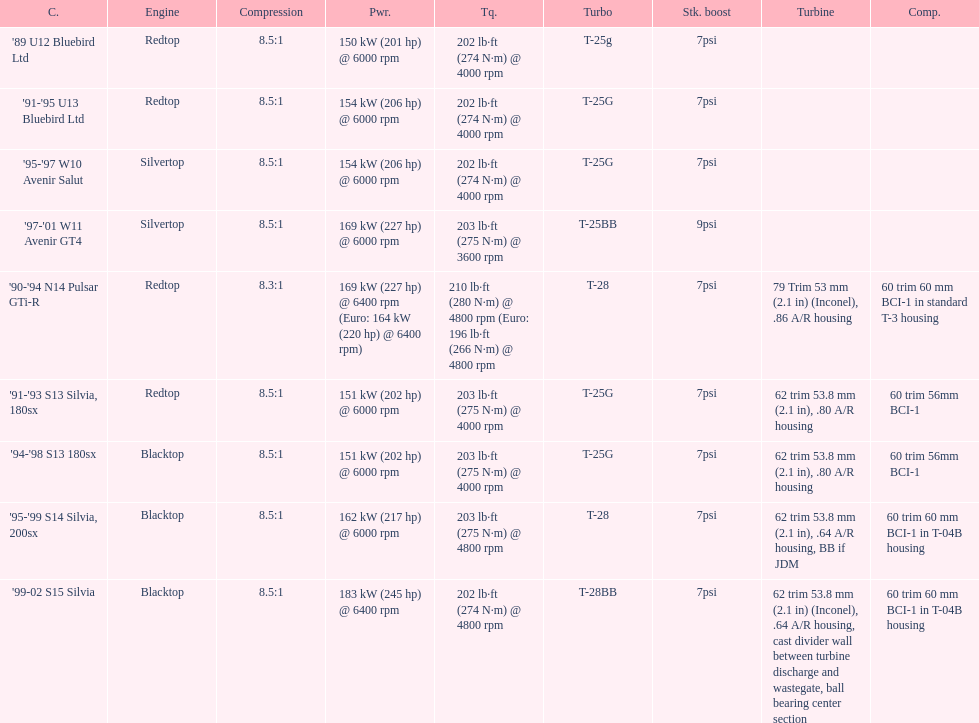How many models utilized the redtop engine? 4. 